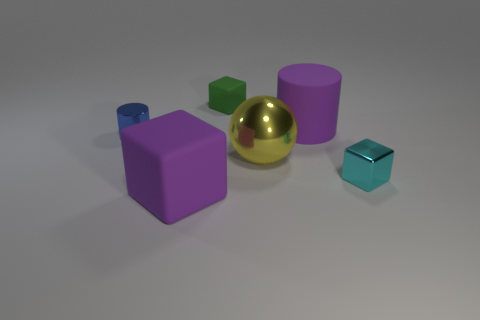Can you estimate the dimensions of the purple cube relative to the others? While exact measurements cannot be derived from the image alone, the purple cube in the image appears to be roughly twice the size of the tiny green cube and about equal in size to the cyan-colored cube nearby. Its dimension might be in a standard proportion range, suggesting a side length approximately double that of the smallest cubes. 